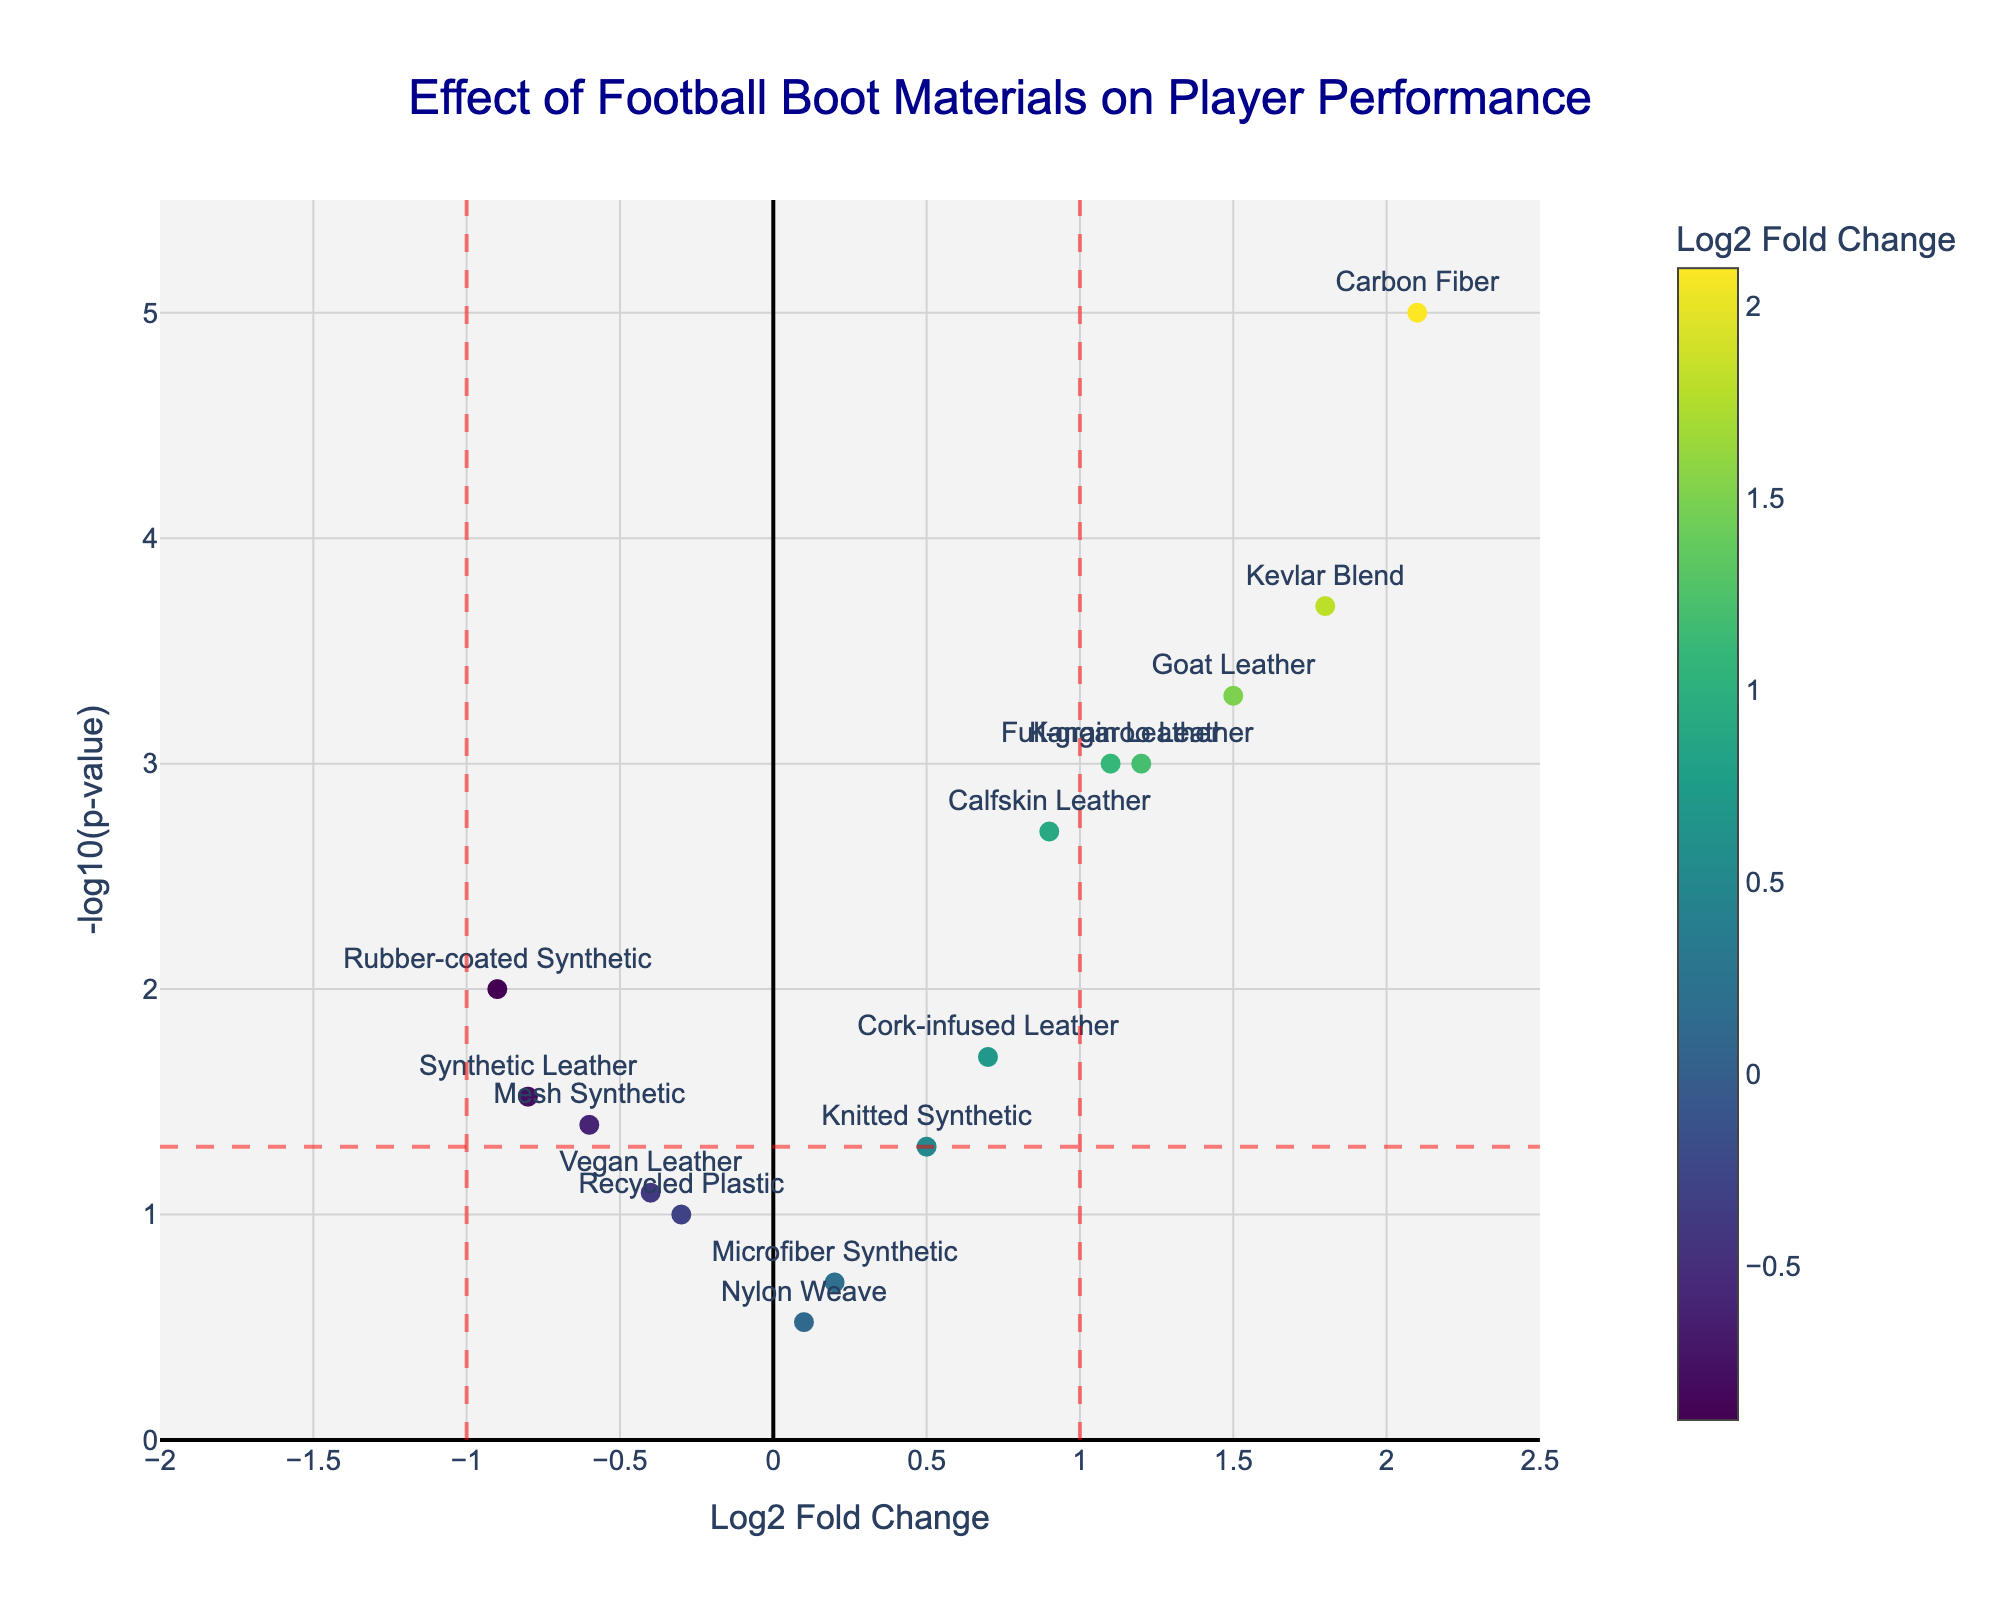What's the title of the figure? The title is usually located at the top part of the figure. Observing the plot, the title reads "Effect of Football Boot Materials on Player Performance".
Answer: Effect of Football Boot Materials on Player Performance How many materials have a Log2 Fold Change above 1? Materials with Log2 Fold Change above 1 are within the positive area to the right of the vertical line at x=1. These include Kangaroo Leather, Calfskin Leather, Goat Leather, Carbon Fiber, Full-grain Leather, Kevlar Blend. There are 6 materials in total.
Answer: 6 Which material has the highest significance based on p-value? The significance is represented by the -log10(p-value) on the y-axis. The material with the highest value (y) is Carbon Fiber.
Answer: Carbon Fiber Which material has the lowest Log2 Fold Change? The lowest Log2 Fold Change is depicted on the farthest left, which is Rubber-coated Synthetic with a value of -0.9.
Answer: Rubber-coated Synthetic What does a vertical line at x=1 signify in the figure? The vertical line at x=1 marks the boundary where Log2 Fold Change is significant, values to the right indicate a positive change higher than double the response level.
Answer: Significance boundary How many materials have both Log2 Fold Change above 1 and p-value below 0.05? Materials with Log2 Fold Change above 1 and p-value below 0.05 are Kangaroo Leather, Calfskin Leather, Goat Leather, Carbon Fiber, Full-grain Leather, Kevlar Blend, so there are 6 in total.
Answer: 6 What does a point's y-axis value represent in the plot? The y-axis value represents the -log10(p-value), higher values indicate more significant p-values (lower p-values).
Answer: -log10(p-value) Which material has higher significance: Knit Synthetic or Mesh Synthetic? To compare, we look at the y-axis values (the -log10(p-value)) for both materials. Mesh Synthetic (-log10(0.04)) is slightly more significant than Knit Synthetic (-log10(0.05)).
Answer: Mesh Synthetic What color indicates the Log2 Fold Change of Carbon Fiber? The color of the Carbon Fiber marker corresponds to the colorbar, which is in the lighter yellow shade representing the highest Log2 Fold Change of 2.1.
Answer: Light yellow Among the leather materials, which has the highest Log2 Fold Change? Among the leather materials, Goat Leather has the highest Log2 Fold Change, which is 1.5.
Answer: Goat Leather 